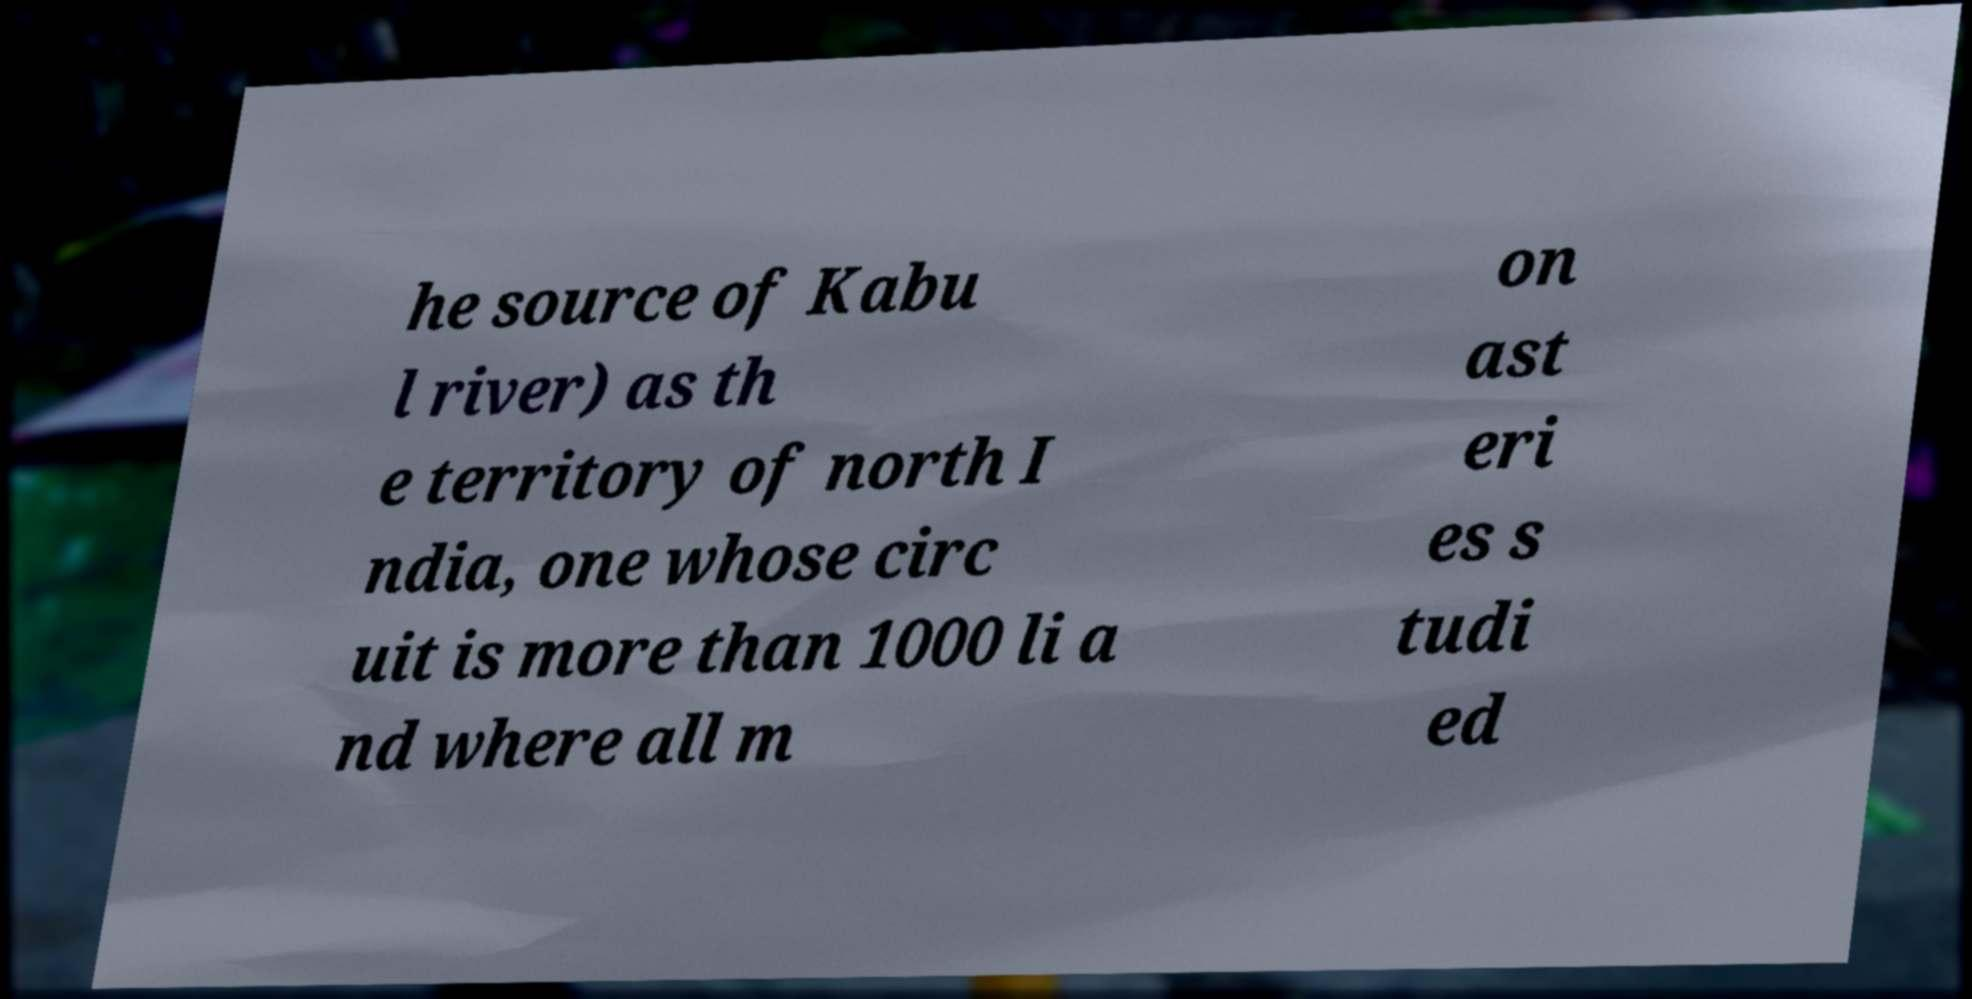Please identify and transcribe the text found in this image. he source of Kabu l river) as th e territory of north I ndia, one whose circ uit is more than 1000 li a nd where all m on ast eri es s tudi ed 